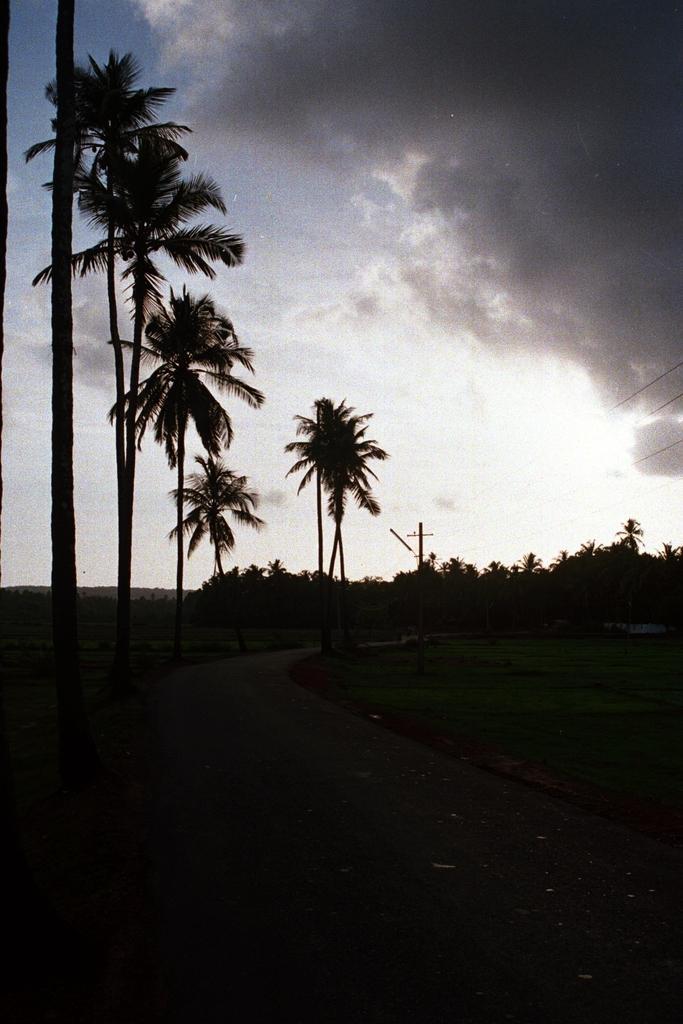Describe this image in one or two sentences. In this picture we can see a few trees from left to right. Sky is cloudy. At the bottom, we can see a dark view. 